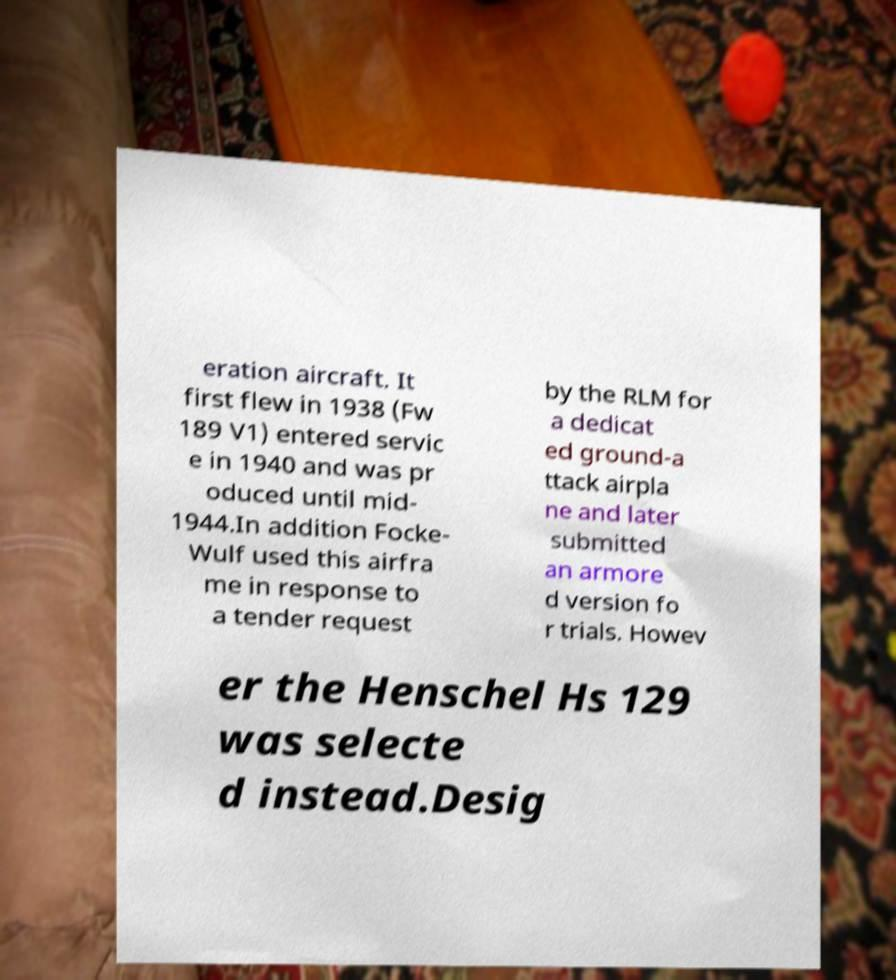For documentation purposes, I need the text within this image transcribed. Could you provide that? eration aircraft. It first flew in 1938 (Fw 189 V1) entered servic e in 1940 and was pr oduced until mid- 1944.In addition Focke- Wulf used this airfra me in response to a tender request by the RLM for a dedicat ed ground-a ttack airpla ne and later submitted an armore d version fo r trials. Howev er the Henschel Hs 129 was selecte d instead.Desig 